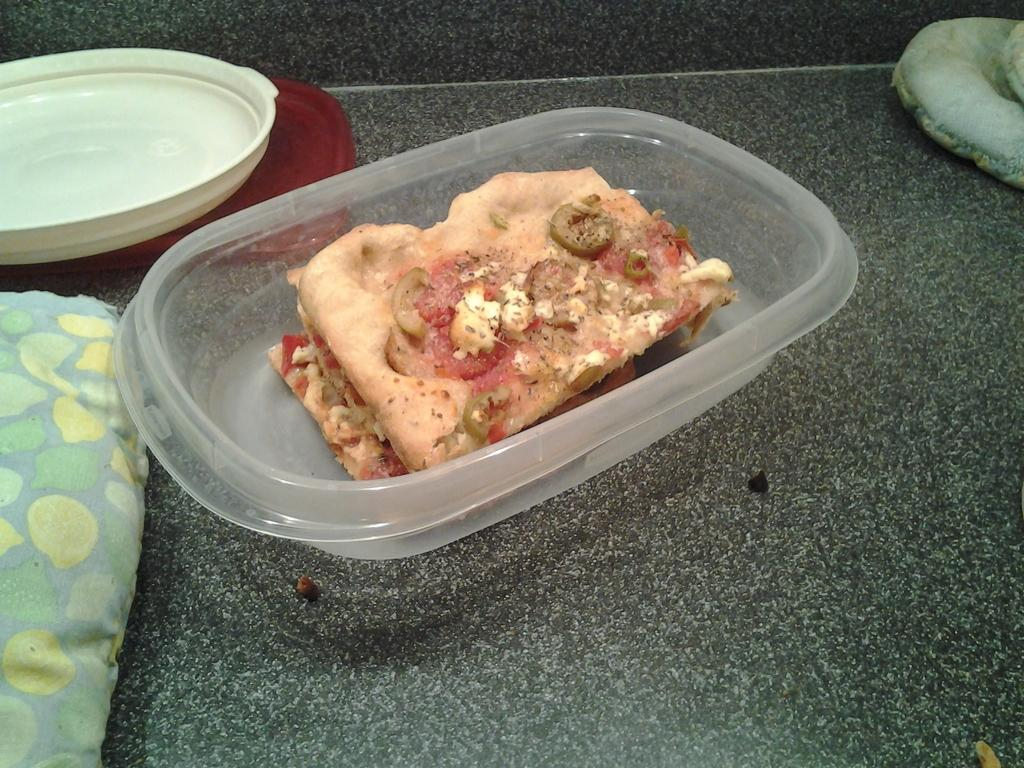What type of container holds the food items in the image? There are food items in a plastic bowl in the image. What other dish can be seen in the image? There is a white color plate on the right side of the image. Where are the bowl and plate located in the image? The bowl and plate are placed on the floor. What is the income of the person who took the picture of the food items? The income of the person who took the picture is not mentioned or visible in the image, so it cannot be determined. 